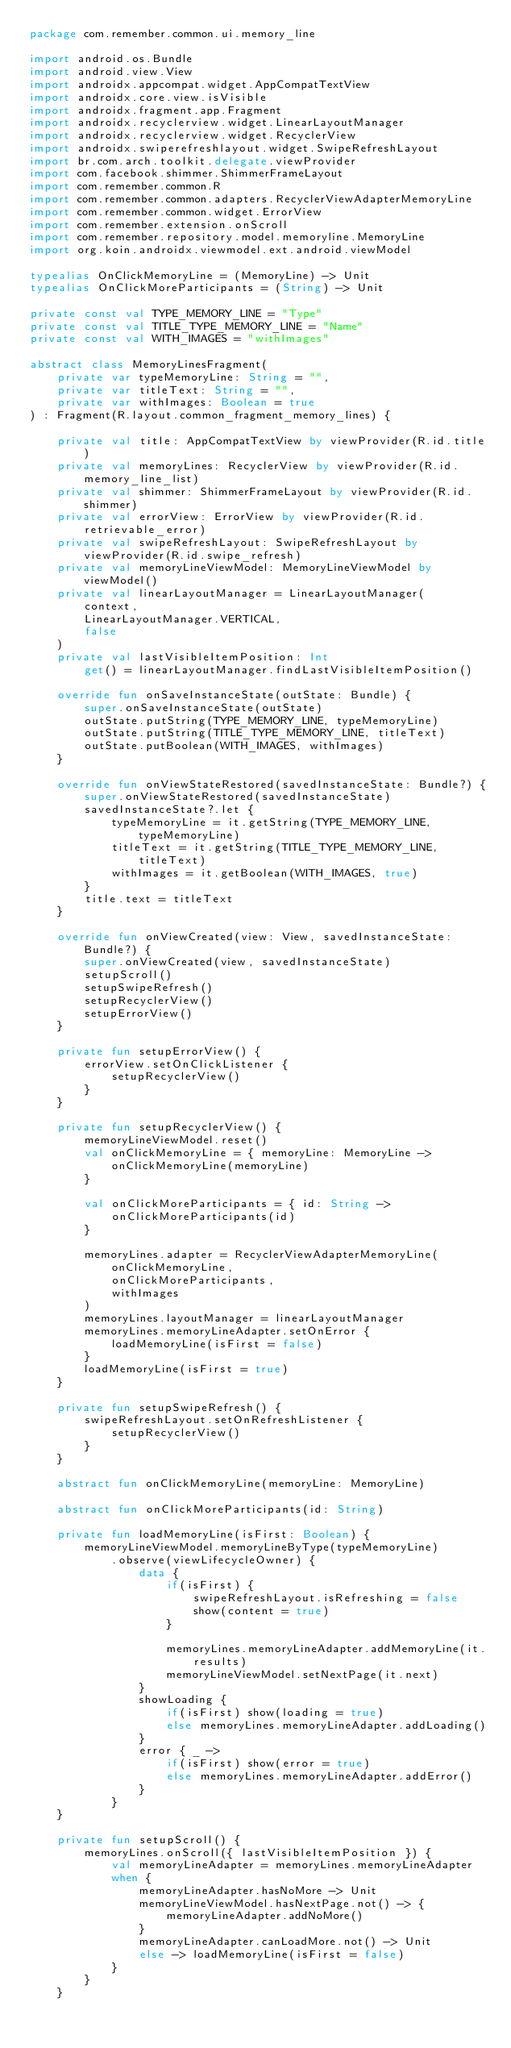<code> <loc_0><loc_0><loc_500><loc_500><_Kotlin_>package com.remember.common.ui.memory_line

import android.os.Bundle
import android.view.View
import androidx.appcompat.widget.AppCompatTextView
import androidx.core.view.isVisible
import androidx.fragment.app.Fragment
import androidx.recyclerview.widget.LinearLayoutManager
import androidx.recyclerview.widget.RecyclerView
import androidx.swiperefreshlayout.widget.SwipeRefreshLayout
import br.com.arch.toolkit.delegate.viewProvider
import com.facebook.shimmer.ShimmerFrameLayout
import com.remember.common.R
import com.remember.common.adapters.RecyclerViewAdapterMemoryLine
import com.remember.common.widget.ErrorView
import com.remember.extension.onScroll
import com.remember.repository.model.memoryline.MemoryLine
import org.koin.androidx.viewmodel.ext.android.viewModel

typealias OnClickMemoryLine = (MemoryLine) -> Unit
typealias OnClickMoreParticipants = (String) -> Unit

private const val TYPE_MEMORY_LINE = "Type"
private const val TITLE_TYPE_MEMORY_LINE = "Name"
private const val WITH_IMAGES = "withImages"

abstract class MemoryLinesFragment(
    private var typeMemoryLine: String = "",
    private var titleText: String = "",
    private var withImages: Boolean = true
) : Fragment(R.layout.common_fragment_memory_lines) {

    private val title: AppCompatTextView by viewProvider(R.id.title)
    private val memoryLines: RecyclerView by viewProvider(R.id.memory_line_list)
    private val shimmer: ShimmerFrameLayout by viewProvider(R.id.shimmer)
    private val errorView: ErrorView by viewProvider(R.id.retrievable_error)
    private val swipeRefreshLayout: SwipeRefreshLayout by viewProvider(R.id.swipe_refresh)
    private val memoryLineViewModel: MemoryLineViewModel by viewModel()
    private val linearLayoutManager = LinearLayoutManager(
        context,
        LinearLayoutManager.VERTICAL,
        false
    )
    private val lastVisibleItemPosition: Int
        get() = linearLayoutManager.findLastVisibleItemPosition()

    override fun onSaveInstanceState(outState: Bundle) {
        super.onSaveInstanceState(outState)
        outState.putString(TYPE_MEMORY_LINE, typeMemoryLine)
        outState.putString(TITLE_TYPE_MEMORY_LINE, titleText)
        outState.putBoolean(WITH_IMAGES, withImages)
    }

    override fun onViewStateRestored(savedInstanceState: Bundle?) {
        super.onViewStateRestored(savedInstanceState)
        savedInstanceState?.let {
            typeMemoryLine = it.getString(TYPE_MEMORY_LINE, typeMemoryLine)
            titleText = it.getString(TITLE_TYPE_MEMORY_LINE, titleText)
            withImages = it.getBoolean(WITH_IMAGES, true)
        }
        title.text = titleText
    }

    override fun onViewCreated(view: View, savedInstanceState: Bundle?) {
        super.onViewCreated(view, savedInstanceState)
        setupScroll()
        setupSwipeRefresh()
        setupRecyclerView()
        setupErrorView()
    }

    private fun setupErrorView() {
        errorView.setOnClickListener {
            setupRecyclerView()
        }
    }

    private fun setupRecyclerView() {
        memoryLineViewModel.reset()
        val onClickMemoryLine = { memoryLine: MemoryLine ->
            onClickMemoryLine(memoryLine)
        }

        val onClickMoreParticipants = { id: String ->
            onClickMoreParticipants(id)
        }

        memoryLines.adapter = RecyclerViewAdapterMemoryLine(
            onClickMemoryLine,
            onClickMoreParticipants,
            withImages
        )
        memoryLines.layoutManager = linearLayoutManager
        memoryLines.memoryLineAdapter.setOnError {
            loadMemoryLine(isFirst = false)
        }
        loadMemoryLine(isFirst = true)
    }

    private fun setupSwipeRefresh() {
        swipeRefreshLayout.setOnRefreshListener {
            setupRecyclerView()
        }
    }

    abstract fun onClickMemoryLine(memoryLine: MemoryLine)

    abstract fun onClickMoreParticipants(id: String)

    private fun loadMemoryLine(isFirst: Boolean) {
        memoryLineViewModel.memoryLineByType(typeMemoryLine)
            .observe(viewLifecycleOwner) {
                data {
                    if(isFirst) {
                        swipeRefreshLayout.isRefreshing = false
                        show(content = true)
                    }

                    memoryLines.memoryLineAdapter.addMemoryLine(it.results)
                    memoryLineViewModel.setNextPage(it.next)
                }
                showLoading {
                    if(isFirst) show(loading = true)
                    else memoryLines.memoryLineAdapter.addLoading()
                }
                error { _ ->
                    if(isFirst) show(error = true)
                    else memoryLines.memoryLineAdapter.addError()
                }
            }
    }

    private fun setupScroll() {
        memoryLines.onScroll({ lastVisibleItemPosition }) {
            val memoryLineAdapter = memoryLines.memoryLineAdapter
            when {
                memoryLineAdapter.hasNoMore -> Unit
                memoryLineViewModel.hasNextPage.not() -> {
                    memoryLineAdapter.addNoMore()
                }
                memoryLineAdapter.canLoadMore.not() -> Unit
                else -> loadMemoryLine(isFirst = false)
            }
        }
    }
</code> 